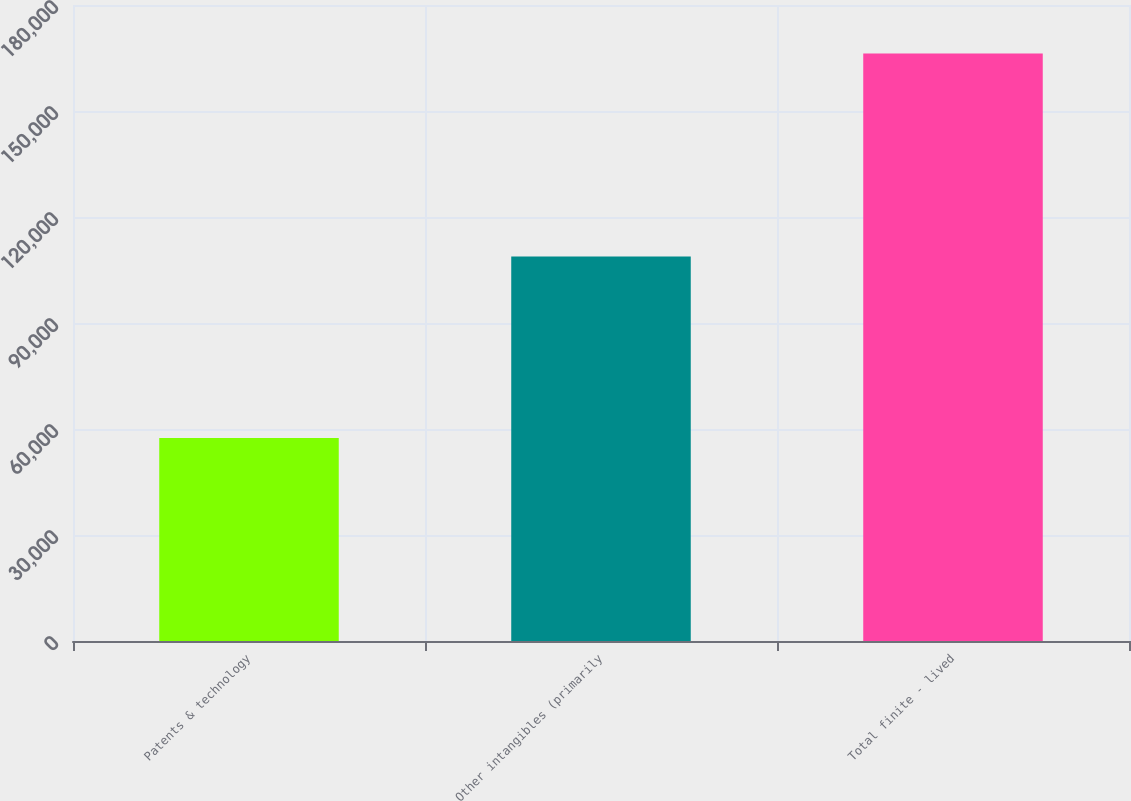<chart> <loc_0><loc_0><loc_500><loc_500><bar_chart><fcel>Patents & technology<fcel>Other intangibles (primarily<fcel>Total finite - lived<nl><fcel>57434<fcel>108833<fcel>166267<nl></chart> 